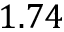Convert formula to latex. <formula><loc_0><loc_0><loc_500><loc_500>1 . 7 4</formula> 